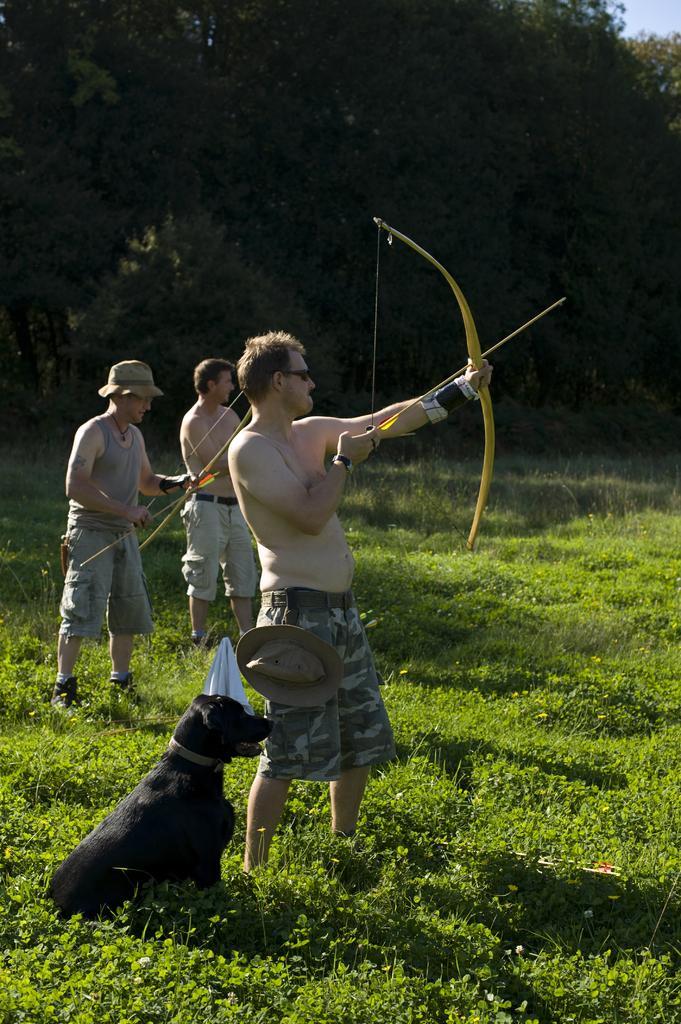In one or two sentences, can you explain what this image depicts? In the center of the image we can see persons holding bow and arrow. At the bottom of the image we can see dog and grass. In the background we can see trees, grass and sky. 